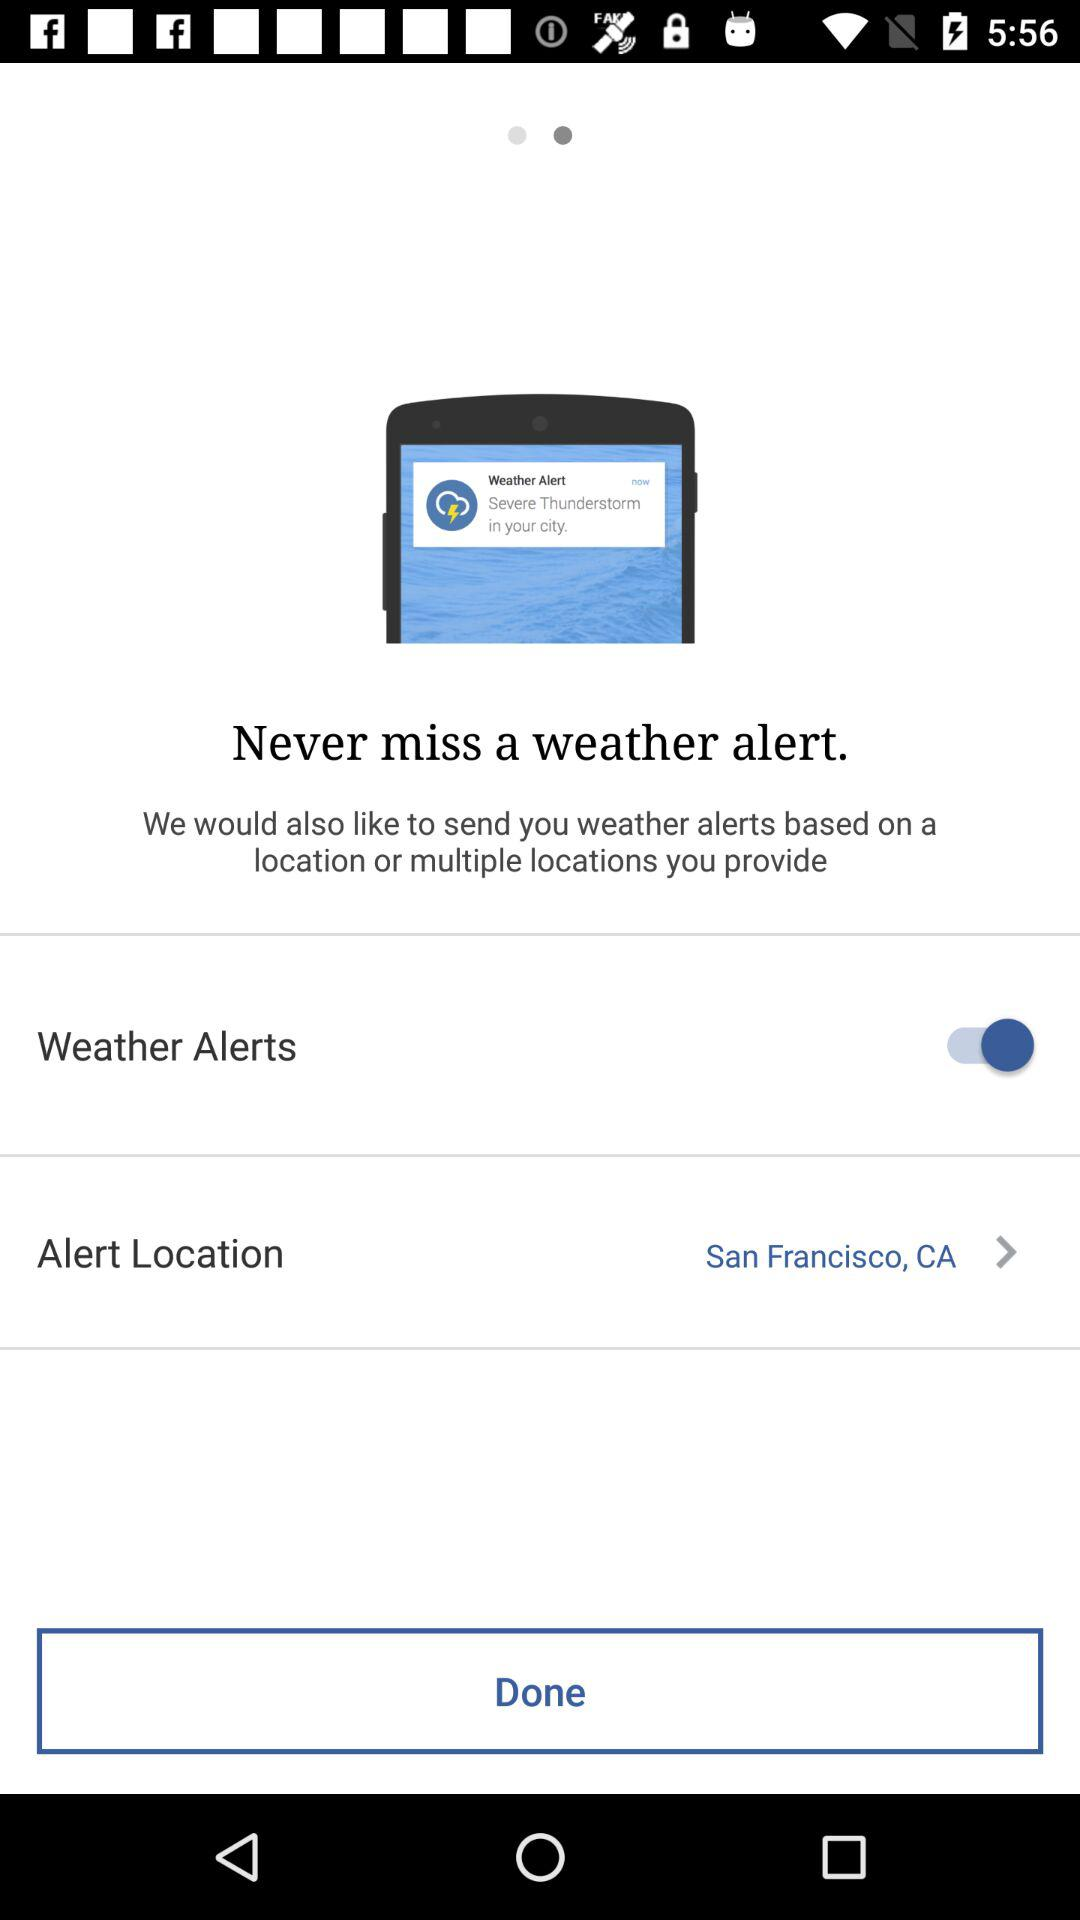What is the current alert location? The current alert location is San Francisco, CA. 